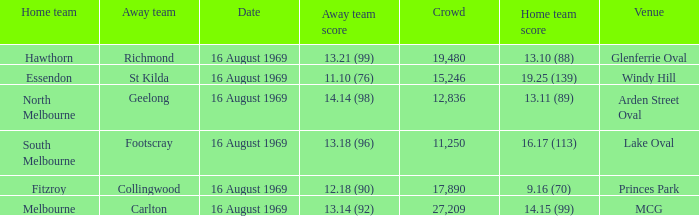What was the away team's score at Princes Park? 12.18 (90). 